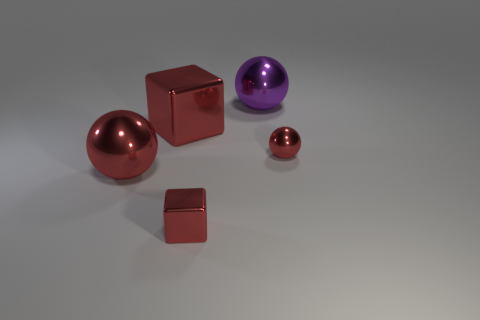What could be the significance of the size difference between the objects? The varying sizes of the objects in the image could be a study of scale and perspective, or they could symbolize a hierarchy or progression. For instance, in a symbolic context, larger objects might represent concepts or entities of greater significance or power, while smaller ones might imply minor elements or details. 